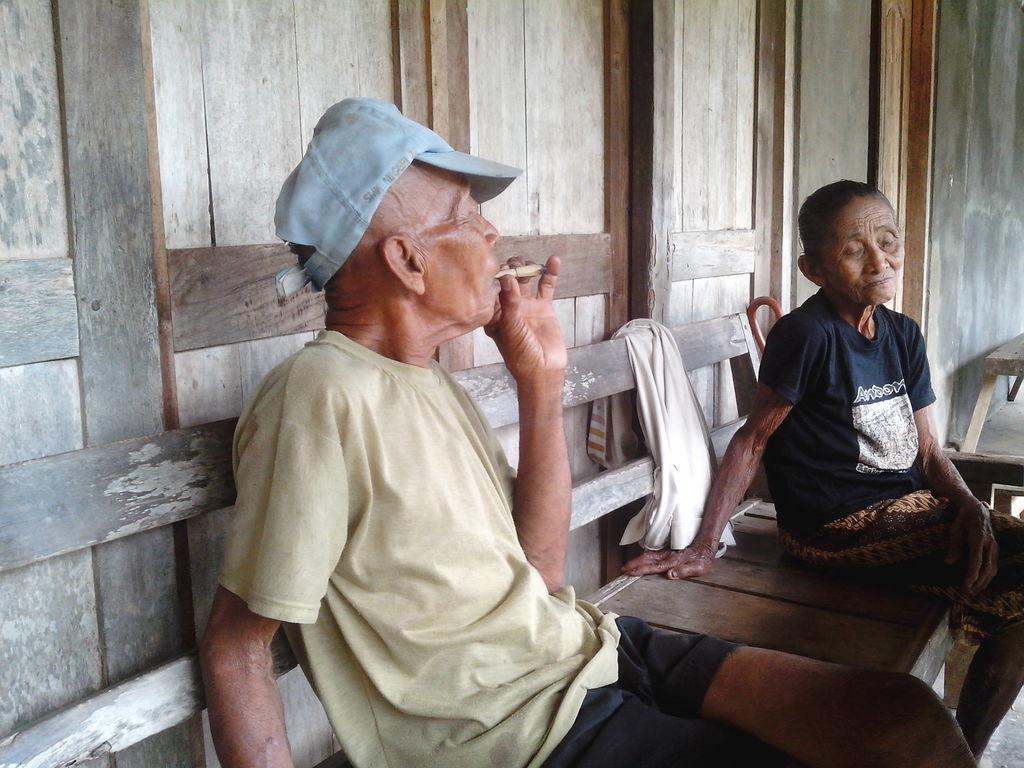What is the man in the image doing? The man is sitting on a bench in the image. What is the man holding in the image? The man is holding a cigar. Who is sitting next to the man? There is a lady sitting next to the man. What can be seen in the background of the image? There is a wall and a cloth visible in the background. What type of floor can be seen in the image? There is no floor visible in the image; it only shows a man, a lady, and a bench. Is there a crib present in the image? No, there is no crib present in the image. 